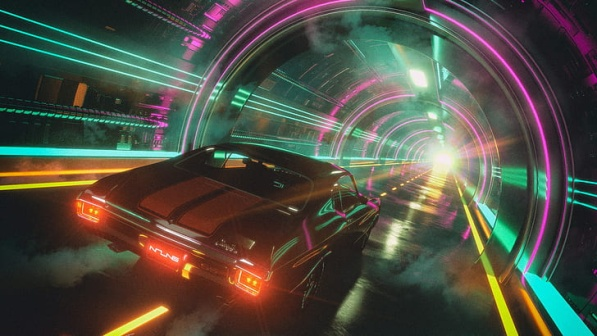How do you think this image reflects the atmosphere and culture of the city it portrays? The image captures an electrifying atmosphere that reflects a city pulsating with energy and technological advancements. The vibrant neon lights and futuristic architectural design suggest a culture that thrives on innovation and high-tech aesthetics. The presence of a sleek sports car in motion indicates a society that values speed, modernity, and perhaps a sense of rebellion or independence. The city's distant skyline, filled with towering structures, speaks to a sprawling urban environment where the possibilities seem endless and the boundaries between technology and everyday life are seamlessly integrated. Can you describe a day in the life of a typical resident of this city? A typical day for a Neo-Metropolis resident starts with the gentle hum of autonomous drones delivering the morning news via holographic displays in their high-rise apartments. Residents engage in virtual workspaces, connecting with colleagues globally through immersive VR technology. During their breaks, they might visit neon-lit cyberspaces or lounges suspended in the air, where they socialize and experience digital art forms. Transportation revolves around flying cars or high-speed trains that navigate the intricate cityscape. Evenings are marked by citywide light shows and interactive entertainment, blending digital and physical realms. Amidst this high-tech lifestyle, there's a growing subculture that cherishes traditional aspects and physical experiences, creating a blend of the old and the new in this luminous urban sprawl.  Imagine if this tunnel was actually a portal. Where do you think it could lead? Imagine if this tunnel was a portal that transported travelers to parallel dimensions. As the sports car races towards the blinding white light at the tunnel's end, it transcends space and time, emerging into a realm where the laws of physics are fluid and imagination reigns. This otherworldly domain is a kaleidoscope of floating cities, inhabited by beings of light and shadow, each realm reflecting a different aspect of consciousness and reality. Visitors find themselves navigating landscapes of dreams where their deepest desires and fears manifest before them. The tunnel is more than just a passage; it's a gateway to the infinite possibilities of the multiverse. 